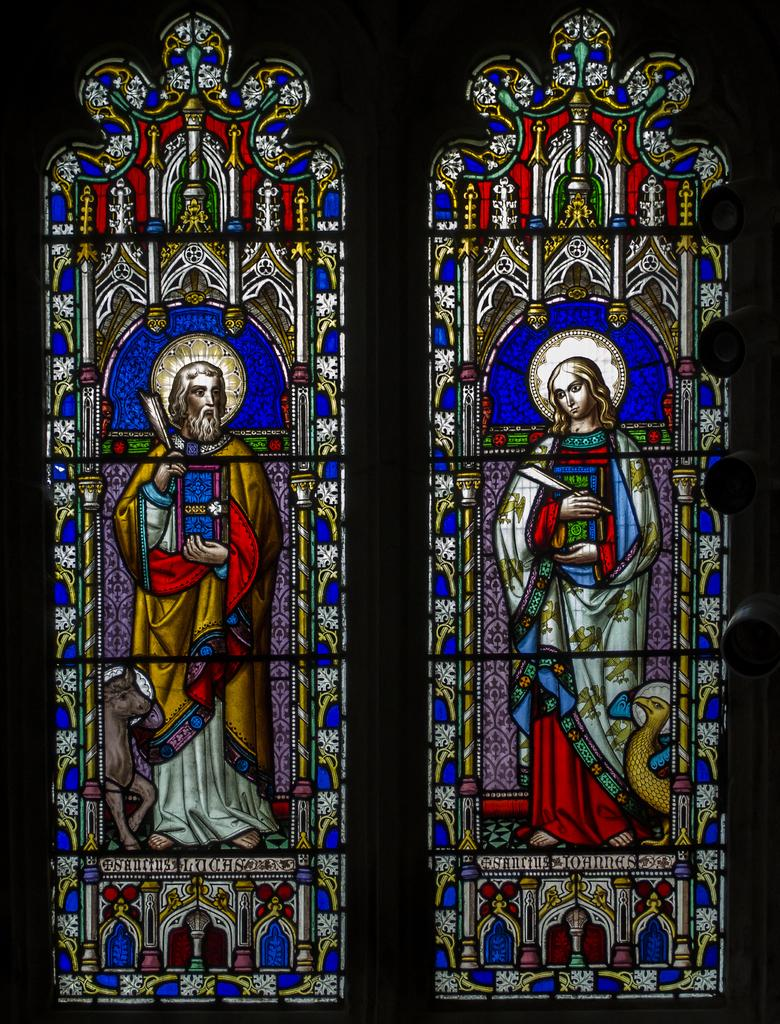What type of accessory is present in the image? There are designer glasses in the image. Where are the designer glasses located in relation to other elements in the image? The designer glasses are near a window. Can you see a bee buzzing around the designer glasses in the image? No, there is no bee present in the image. 